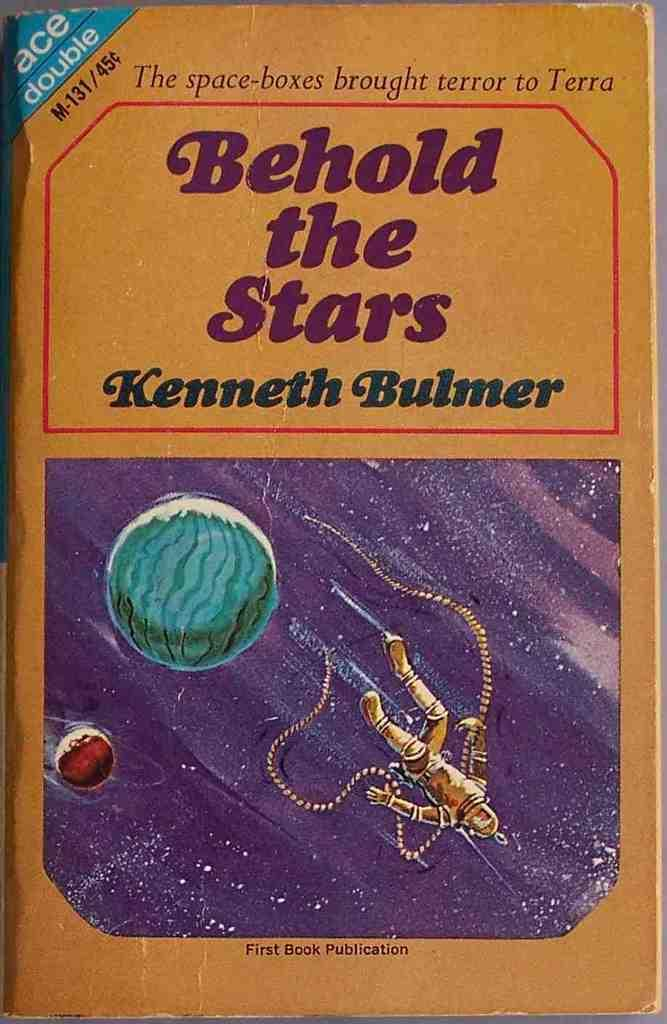<image>
Offer a succinct explanation of the picture presented. A book by Kenneth Bulmer titled Behold the Stars 